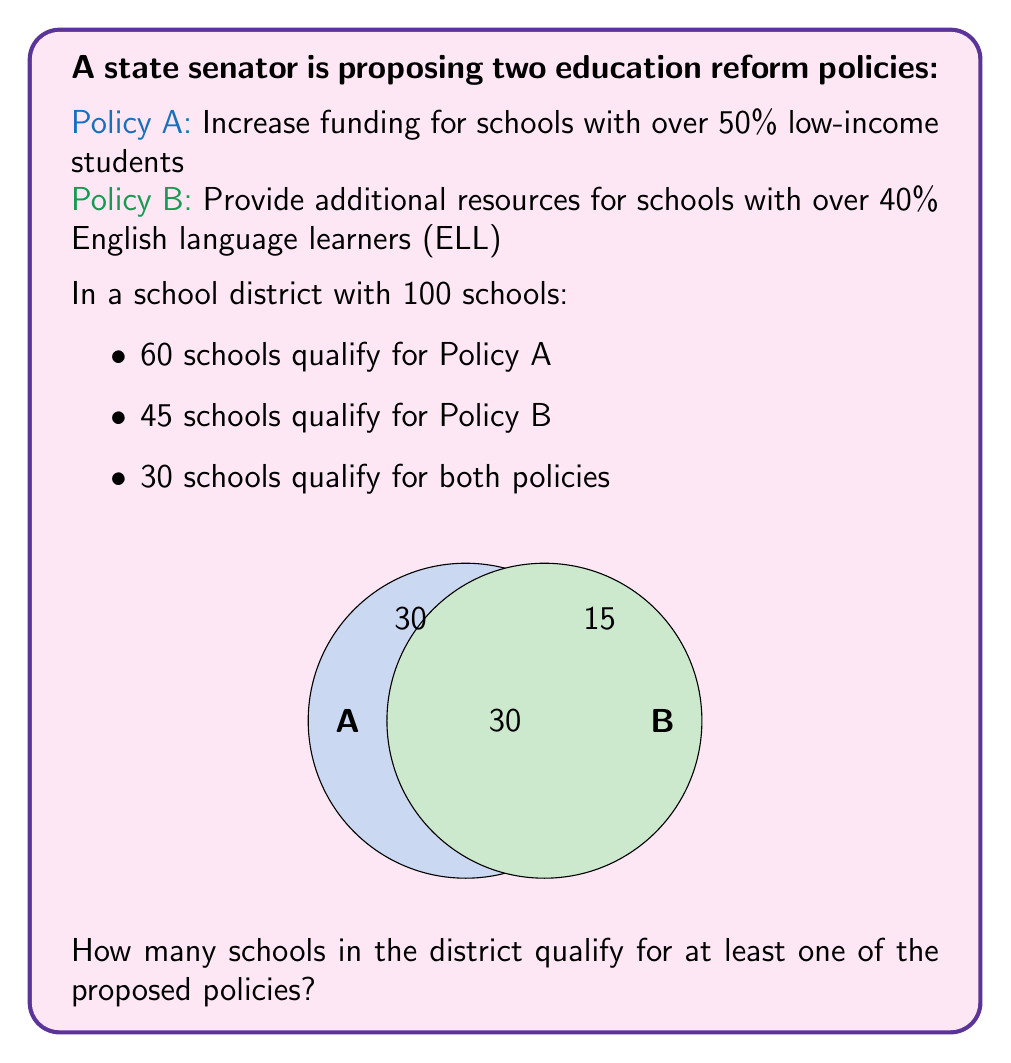Give your solution to this math problem. To solve this problem, we can use the principle of inclusion-exclusion from set theory.

Let's define:
- Set A: Schools qualifying for Policy A
- Set B: Schools qualifying for Policy B

We're given:
1. $|A| = 60$ (number of schools in set A)
2. $|B| = 45$ (number of schools in set B)
3. $|A \cap B| = 30$ (number of schools in both A and B)

The principle of inclusion-exclusion states:

$|A \cup B| = |A| + |B| - |A \cap B|$

Where $|A \cup B|$ represents the number of schools qualifying for at least one policy.

Substituting the given values:

$|A \cup B| = 60 + 45 - 30 = 75$

Therefore, 75 schools qualify for at least one of the proposed policies.
Answer: 75 schools 